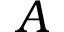<formula> <loc_0><loc_0><loc_500><loc_500>A</formula> 